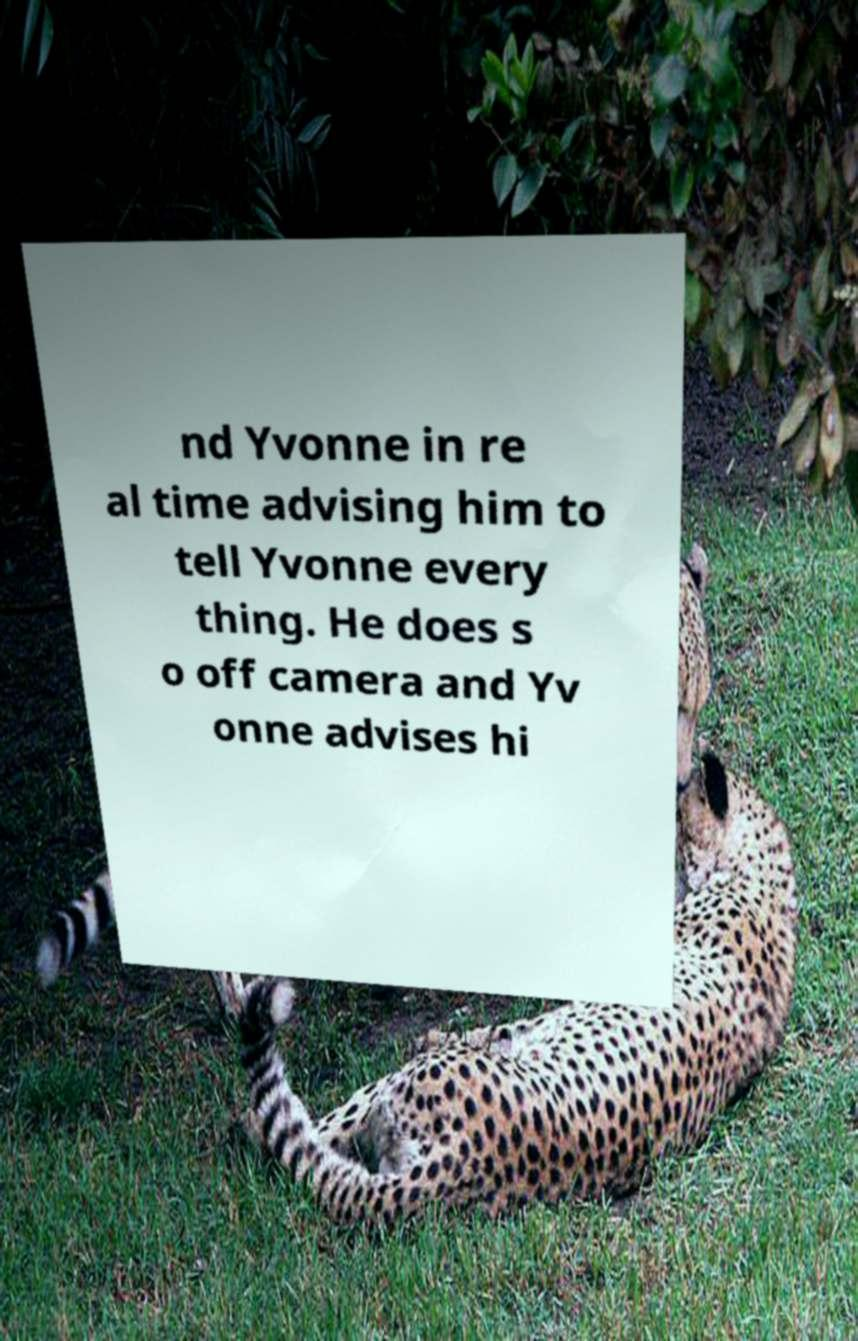Could you assist in decoding the text presented in this image and type it out clearly? nd Yvonne in re al time advising him to tell Yvonne every thing. He does s o off camera and Yv onne advises hi 